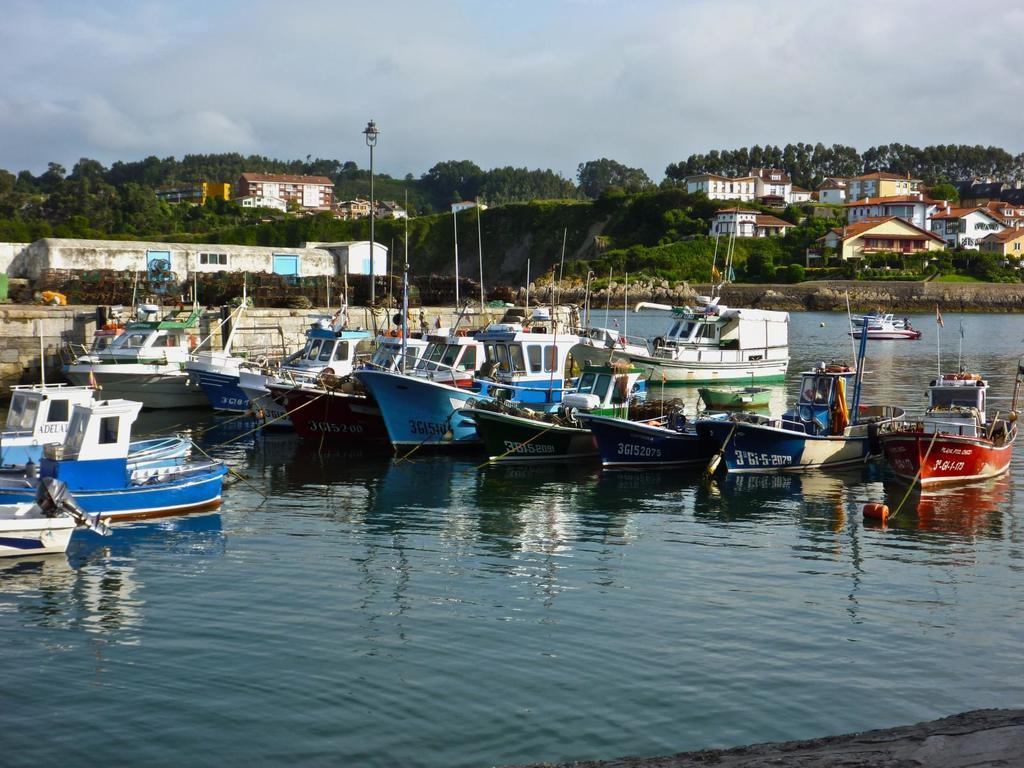What is floating on the water in the image? There are boats floating on the water in the image. What can be seen in the background of the image? There are houses, trees, light poles, and a cloudy sky in the background of the image. Where is the van parked in the image? There is no van present in the image. How many ducks are swimming near the boats in the image? There are no ducks visible in the image; only boats are present on the water. 